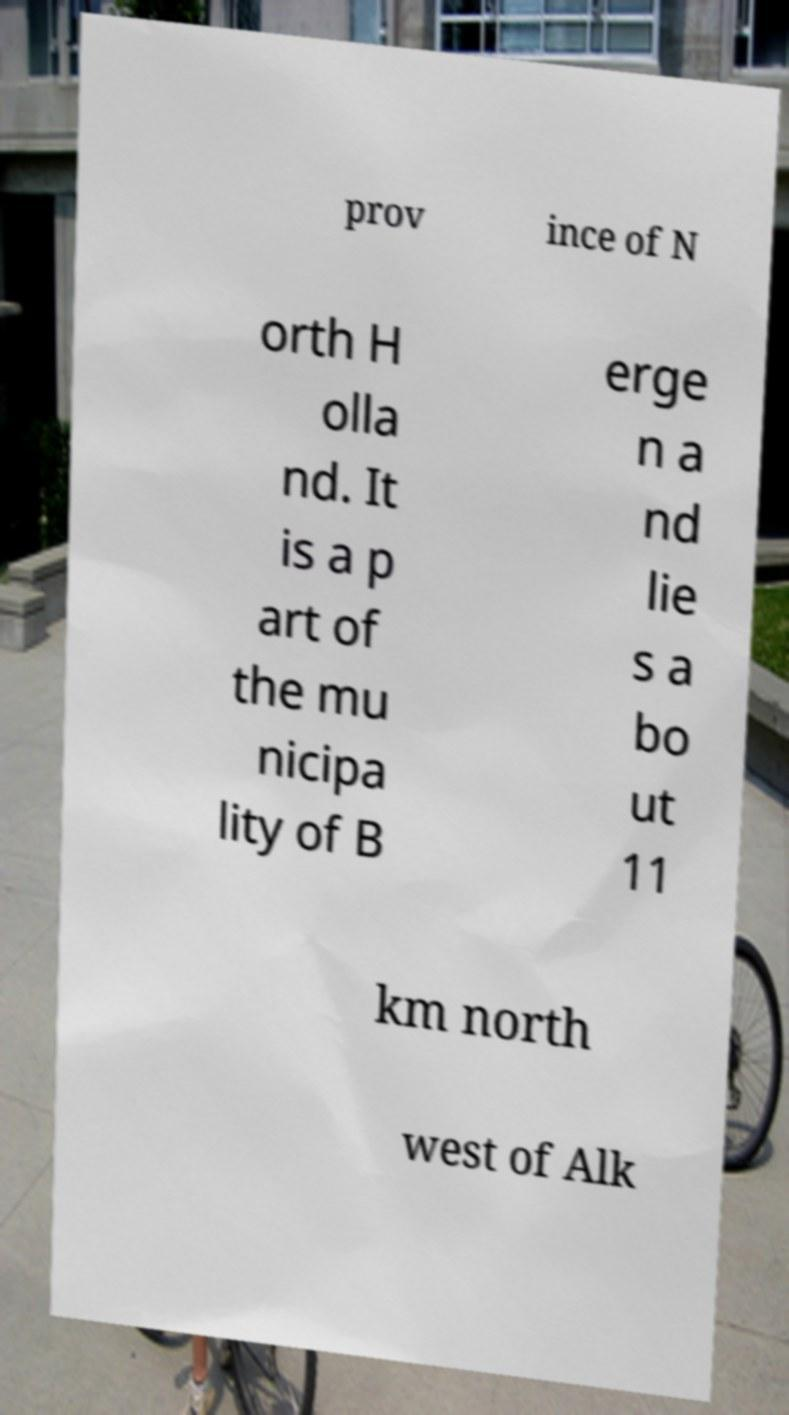I need the written content from this picture converted into text. Can you do that? prov ince of N orth H olla nd. It is a p art of the mu nicipa lity of B erge n a nd lie s a bo ut 11 km north west of Alk 